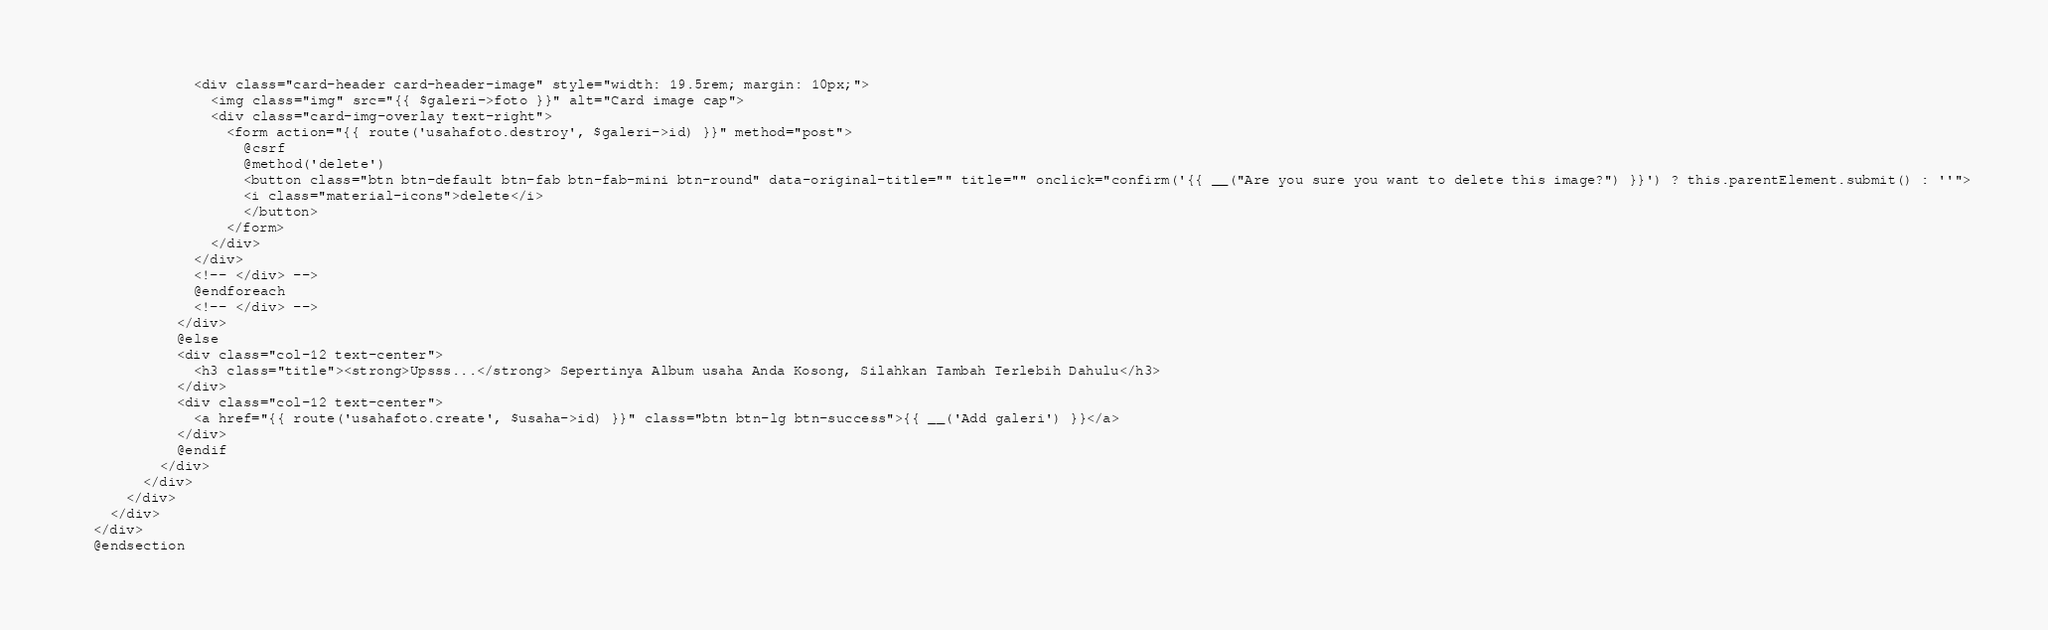Convert code to text. <code><loc_0><loc_0><loc_500><loc_500><_PHP_>              <div class="card-header card-header-image" style="width: 19.5rem; margin: 10px;">
                <img class="img" src="{{ $galeri->foto }}" alt="Card image cap">
                <div class="card-img-overlay text-right">
                  <form action="{{ route('usahafoto.destroy', $galeri->id) }}" method="post">
                    @csrf
                    @method('delete')
                    <button class="btn btn-default btn-fab btn-fab-mini btn-round" data-original-title="" title="" onclick="confirm('{{ __("Are you sure you want to delete this image?") }}') ? this.parentElement.submit() : ''">
                    <i class="material-icons">delete</i>
                    </button>
                  </form>
                </div>
              </div>
              <!-- </div> -->
              @endforeach
              <!-- </div> -->
            </div>
            @else
            <div class="col-12 text-center">
              <h3 class="title"><strong>Upsss...</strong> Sepertinya Album usaha Anda Kosong, Silahkan Tambah Terlebih Dahulu</h3>
            </div>
            <div class="col-12 text-center">
              <a href="{{ route('usahafoto.create', $usaha->id) }}" class="btn btn-lg btn-success">{{ __('Add galeri') }}</a>
            </div>
            @endif
          </div>
        </div>
      </div>
    </div>
  </div>
  @endsection</code> 